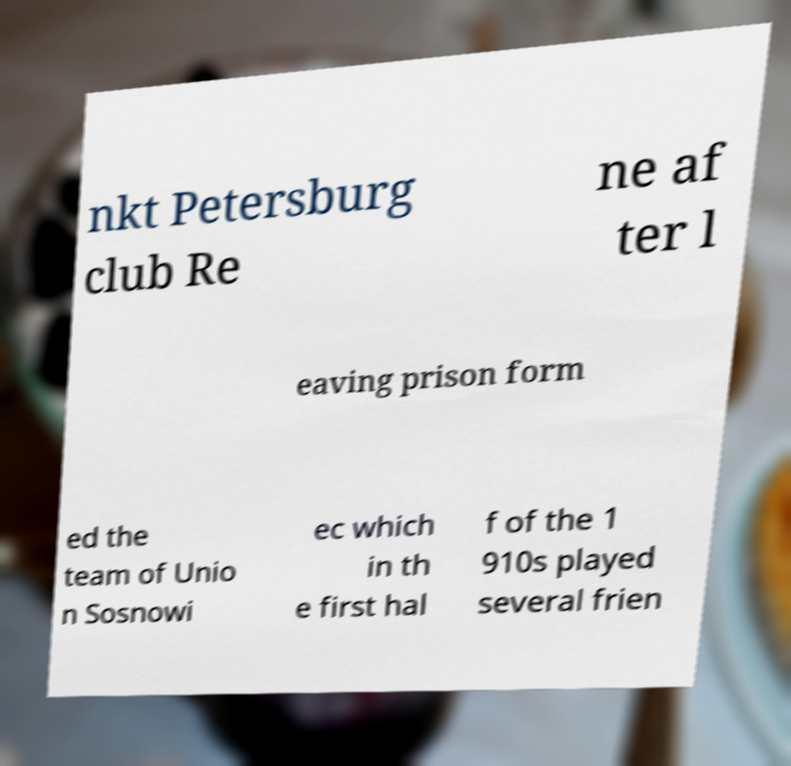There's text embedded in this image that I need extracted. Can you transcribe it verbatim? nkt Petersburg club Re ne af ter l eaving prison form ed the team of Unio n Sosnowi ec which in th e first hal f of the 1 910s played several frien 